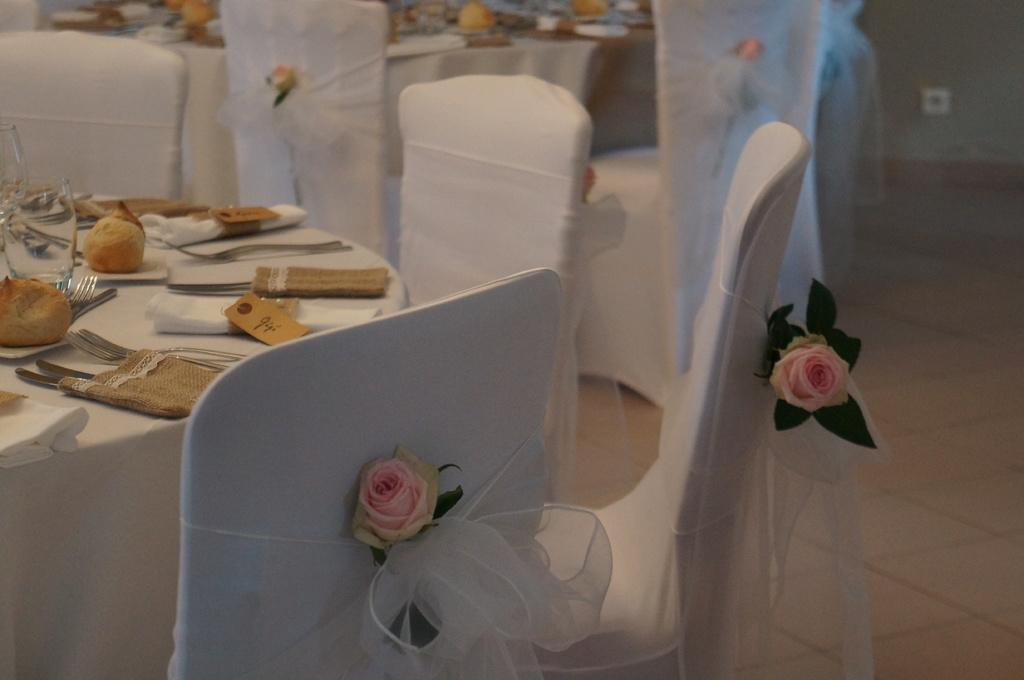What is the main piece of furniture in the image? There is a table in the image. What is on top of the table? There are things placed on the table. What type of seating is available around the table? There are chairs around the table. What decorative element is present on the chairs? Roses are pasted on the chairs. Where is the mine located in the image? There is no mine present in the image. What type of cannon is placed on the table in the image? There is no cannon present in the image. 